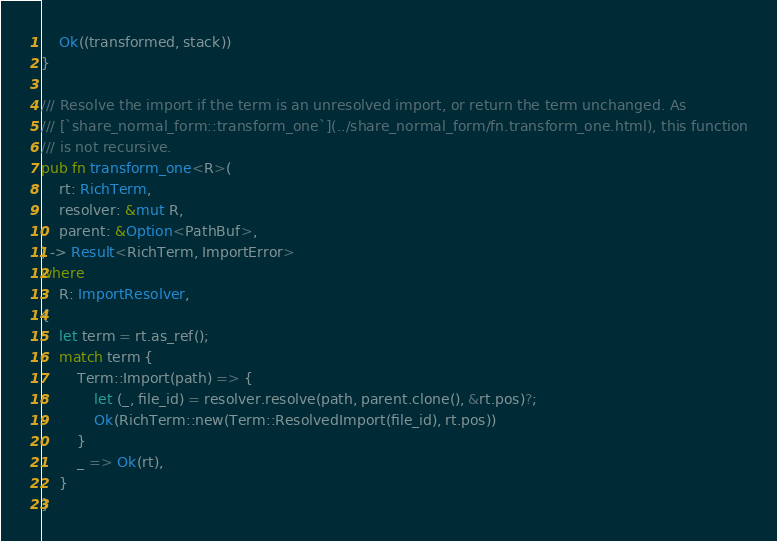Convert code to text. <code><loc_0><loc_0><loc_500><loc_500><_Rust_>    Ok((transformed, stack))
}

/// Resolve the import if the term is an unresolved import, or return the term unchanged. As
/// [`share_normal_form::transform_one`](../share_normal_form/fn.transform_one.html), this function
/// is not recursive.
pub fn transform_one<R>(
    rt: RichTerm,
    resolver: &mut R,
    parent: &Option<PathBuf>,
) -> Result<RichTerm, ImportError>
where
    R: ImportResolver,
{
    let term = rt.as_ref();
    match term {
        Term::Import(path) => {
            let (_, file_id) = resolver.resolve(path, parent.clone(), &rt.pos)?;
            Ok(RichTerm::new(Term::ResolvedImport(file_id), rt.pos))
        }
        _ => Ok(rt),
    }
}
</code> 